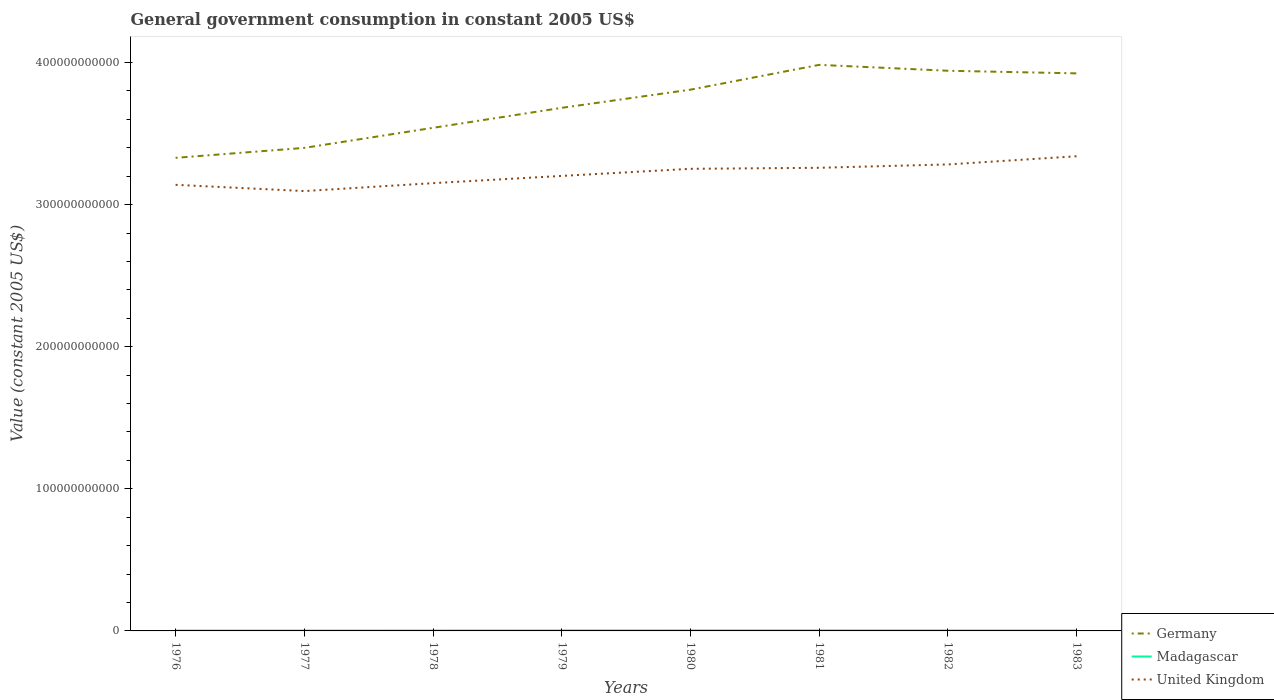How many different coloured lines are there?
Make the answer very short. 3. Does the line corresponding to Germany intersect with the line corresponding to Madagascar?
Keep it short and to the point. No. Across all years, what is the maximum government conusmption in Germany?
Your answer should be very brief. 3.33e+11. In which year was the government conusmption in United Kingdom maximum?
Provide a succinct answer. 1977. What is the total government conusmption in Germany in the graph?
Give a very brief answer. 4.15e+09. What is the difference between the highest and the second highest government conusmption in Madagascar?
Give a very brief answer. 7.58e+07. What is the difference between the highest and the lowest government conusmption in Madagascar?
Offer a terse response. 5. Is the government conusmption in United Kingdom strictly greater than the government conusmption in Madagascar over the years?
Your answer should be very brief. No. What is the difference between two consecutive major ticks on the Y-axis?
Provide a short and direct response. 1.00e+11. What is the title of the graph?
Provide a short and direct response. General government consumption in constant 2005 US$. Does "South Africa" appear as one of the legend labels in the graph?
Give a very brief answer. No. What is the label or title of the Y-axis?
Offer a very short reply. Value (constant 2005 US$). What is the Value (constant 2005 US$) of Germany in 1976?
Ensure brevity in your answer.  3.33e+11. What is the Value (constant 2005 US$) of Madagascar in 1976?
Keep it short and to the point. 2.77e+08. What is the Value (constant 2005 US$) in United Kingdom in 1976?
Ensure brevity in your answer.  3.14e+11. What is the Value (constant 2005 US$) of Germany in 1977?
Your answer should be compact. 3.40e+11. What is the Value (constant 2005 US$) in Madagascar in 1977?
Your answer should be compact. 2.79e+08. What is the Value (constant 2005 US$) of United Kingdom in 1977?
Your answer should be very brief. 3.10e+11. What is the Value (constant 2005 US$) of Germany in 1978?
Give a very brief answer. 3.54e+11. What is the Value (constant 2005 US$) in Madagascar in 1978?
Offer a terse response. 2.95e+08. What is the Value (constant 2005 US$) in United Kingdom in 1978?
Offer a very short reply. 3.15e+11. What is the Value (constant 2005 US$) in Germany in 1979?
Your answer should be compact. 3.68e+11. What is the Value (constant 2005 US$) in Madagascar in 1979?
Offer a terse response. 3.37e+08. What is the Value (constant 2005 US$) of United Kingdom in 1979?
Offer a terse response. 3.20e+11. What is the Value (constant 2005 US$) of Germany in 1980?
Offer a terse response. 3.81e+11. What is the Value (constant 2005 US$) in Madagascar in 1980?
Ensure brevity in your answer.  3.53e+08. What is the Value (constant 2005 US$) in United Kingdom in 1980?
Your answer should be compact. 3.25e+11. What is the Value (constant 2005 US$) in Germany in 1981?
Make the answer very short. 3.98e+11. What is the Value (constant 2005 US$) of Madagascar in 1981?
Your answer should be compact. 3.52e+08. What is the Value (constant 2005 US$) of United Kingdom in 1981?
Your answer should be very brief. 3.26e+11. What is the Value (constant 2005 US$) of Germany in 1982?
Your response must be concise. 3.94e+11. What is the Value (constant 2005 US$) in Madagascar in 1982?
Ensure brevity in your answer.  3.42e+08. What is the Value (constant 2005 US$) in United Kingdom in 1982?
Offer a very short reply. 3.28e+11. What is the Value (constant 2005 US$) in Germany in 1983?
Provide a succinct answer. 3.92e+11. What is the Value (constant 2005 US$) of Madagascar in 1983?
Make the answer very short. 3.43e+08. What is the Value (constant 2005 US$) in United Kingdom in 1983?
Keep it short and to the point. 3.34e+11. Across all years, what is the maximum Value (constant 2005 US$) in Germany?
Keep it short and to the point. 3.98e+11. Across all years, what is the maximum Value (constant 2005 US$) of Madagascar?
Ensure brevity in your answer.  3.53e+08. Across all years, what is the maximum Value (constant 2005 US$) of United Kingdom?
Offer a very short reply. 3.34e+11. Across all years, what is the minimum Value (constant 2005 US$) of Germany?
Give a very brief answer. 3.33e+11. Across all years, what is the minimum Value (constant 2005 US$) in Madagascar?
Your answer should be very brief. 2.77e+08. Across all years, what is the minimum Value (constant 2005 US$) of United Kingdom?
Offer a terse response. 3.10e+11. What is the total Value (constant 2005 US$) in Germany in the graph?
Ensure brevity in your answer.  2.96e+12. What is the total Value (constant 2005 US$) in Madagascar in the graph?
Keep it short and to the point. 2.58e+09. What is the total Value (constant 2005 US$) in United Kingdom in the graph?
Make the answer very short. 2.57e+12. What is the difference between the Value (constant 2005 US$) of Germany in 1976 and that in 1977?
Keep it short and to the point. -7.01e+09. What is the difference between the Value (constant 2005 US$) in Madagascar in 1976 and that in 1977?
Provide a succinct answer. -1.78e+06. What is the difference between the Value (constant 2005 US$) of United Kingdom in 1976 and that in 1977?
Make the answer very short. 4.39e+09. What is the difference between the Value (constant 2005 US$) in Germany in 1976 and that in 1978?
Your answer should be very brief. -2.11e+1. What is the difference between the Value (constant 2005 US$) of Madagascar in 1976 and that in 1978?
Keep it short and to the point. -1.78e+07. What is the difference between the Value (constant 2005 US$) of United Kingdom in 1976 and that in 1978?
Give a very brief answer. -1.18e+09. What is the difference between the Value (constant 2005 US$) of Germany in 1976 and that in 1979?
Your answer should be compact. -3.52e+1. What is the difference between the Value (constant 2005 US$) of Madagascar in 1976 and that in 1979?
Keep it short and to the point. -5.98e+07. What is the difference between the Value (constant 2005 US$) in United Kingdom in 1976 and that in 1979?
Offer a terse response. -6.27e+09. What is the difference between the Value (constant 2005 US$) in Germany in 1976 and that in 1980?
Give a very brief answer. -4.80e+1. What is the difference between the Value (constant 2005 US$) in Madagascar in 1976 and that in 1980?
Your response must be concise. -7.58e+07. What is the difference between the Value (constant 2005 US$) of United Kingdom in 1976 and that in 1980?
Provide a short and direct response. -1.13e+1. What is the difference between the Value (constant 2005 US$) of Germany in 1976 and that in 1981?
Offer a very short reply. -6.54e+1. What is the difference between the Value (constant 2005 US$) of Madagascar in 1976 and that in 1981?
Your answer should be compact. -7.52e+07. What is the difference between the Value (constant 2005 US$) in United Kingdom in 1976 and that in 1981?
Your answer should be very brief. -1.20e+1. What is the difference between the Value (constant 2005 US$) of Germany in 1976 and that in 1982?
Your answer should be very brief. -6.13e+1. What is the difference between the Value (constant 2005 US$) in Madagascar in 1976 and that in 1982?
Offer a terse response. -6.45e+07. What is the difference between the Value (constant 2005 US$) of United Kingdom in 1976 and that in 1982?
Keep it short and to the point. -1.43e+1. What is the difference between the Value (constant 2005 US$) in Germany in 1976 and that in 1983?
Keep it short and to the point. -5.94e+1. What is the difference between the Value (constant 2005 US$) of Madagascar in 1976 and that in 1983?
Keep it short and to the point. -6.57e+07. What is the difference between the Value (constant 2005 US$) of United Kingdom in 1976 and that in 1983?
Give a very brief answer. -2.01e+1. What is the difference between the Value (constant 2005 US$) of Germany in 1977 and that in 1978?
Ensure brevity in your answer.  -1.41e+1. What is the difference between the Value (constant 2005 US$) of Madagascar in 1977 and that in 1978?
Offer a very short reply. -1.60e+07. What is the difference between the Value (constant 2005 US$) of United Kingdom in 1977 and that in 1978?
Keep it short and to the point. -5.57e+09. What is the difference between the Value (constant 2005 US$) of Germany in 1977 and that in 1979?
Your answer should be compact. -2.82e+1. What is the difference between the Value (constant 2005 US$) in Madagascar in 1977 and that in 1979?
Provide a short and direct response. -5.80e+07. What is the difference between the Value (constant 2005 US$) of United Kingdom in 1977 and that in 1979?
Your answer should be very brief. -1.07e+1. What is the difference between the Value (constant 2005 US$) of Germany in 1977 and that in 1980?
Keep it short and to the point. -4.10e+1. What is the difference between the Value (constant 2005 US$) in Madagascar in 1977 and that in 1980?
Your response must be concise. -7.40e+07. What is the difference between the Value (constant 2005 US$) of United Kingdom in 1977 and that in 1980?
Ensure brevity in your answer.  -1.57e+1. What is the difference between the Value (constant 2005 US$) of Germany in 1977 and that in 1981?
Provide a succinct answer. -5.84e+1. What is the difference between the Value (constant 2005 US$) of Madagascar in 1977 and that in 1981?
Provide a short and direct response. -7.34e+07. What is the difference between the Value (constant 2005 US$) of United Kingdom in 1977 and that in 1981?
Provide a succinct answer. -1.64e+1. What is the difference between the Value (constant 2005 US$) in Germany in 1977 and that in 1982?
Your response must be concise. -5.43e+1. What is the difference between the Value (constant 2005 US$) of Madagascar in 1977 and that in 1982?
Ensure brevity in your answer.  -6.28e+07. What is the difference between the Value (constant 2005 US$) in United Kingdom in 1977 and that in 1982?
Keep it short and to the point. -1.87e+1. What is the difference between the Value (constant 2005 US$) of Germany in 1977 and that in 1983?
Give a very brief answer. -5.24e+1. What is the difference between the Value (constant 2005 US$) in Madagascar in 1977 and that in 1983?
Keep it short and to the point. -6.39e+07. What is the difference between the Value (constant 2005 US$) of United Kingdom in 1977 and that in 1983?
Make the answer very short. -2.45e+1. What is the difference between the Value (constant 2005 US$) in Germany in 1978 and that in 1979?
Offer a very short reply. -1.41e+1. What is the difference between the Value (constant 2005 US$) in Madagascar in 1978 and that in 1979?
Ensure brevity in your answer.  -4.20e+07. What is the difference between the Value (constant 2005 US$) in United Kingdom in 1978 and that in 1979?
Ensure brevity in your answer.  -5.10e+09. What is the difference between the Value (constant 2005 US$) of Germany in 1978 and that in 1980?
Give a very brief answer. -2.69e+1. What is the difference between the Value (constant 2005 US$) in Madagascar in 1978 and that in 1980?
Your answer should be very brief. -5.80e+07. What is the difference between the Value (constant 2005 US$) in United Kingdom in 1978 and that in 1980?
Give a very brief answer. -1.01e+1. What is the difference between the Value (constant 2005 US$) in Germany in 1978 and that in 1981?
Your response must be concise. -4.43e+1. What is the difference between the Value (constant 2005 US$) in Madagascar in 1978 and that in 1981?
Offer a terse response. -5.74e+07. What is the difference between the Value (constant 2005 US$) in United Kingdom in 1978 and that in 1981?
Make the answer very short. -1.08e+1. What is the difference between the Value (constant 2005 US$) of Germany in 1978 and that in 1982?
Offer a terse response. -4.02e+1. What is the difference between the Value (constant 2005 US$) of Madagascar in 1978 and that in 1982?
Offer a very short reply. -4.68e+07. What is the difference between the Value (constant 2005 US$) in United Kingdom in 1978 and that in 1982?
Provide a short and direct response. -1.32e+1. What is the difference between the Value (constant 2005 US$) in Germany in 1978 and that in 1983?
Make the answer very short. -3.83e+1. What is the difference between the Value (constant 2005 US$) of Madagascar in 1978 and that in 1983?
Your response must be concise. -4.80e+07. What is the difference between the Value (constant 2005 US$) of United Kingdom in 1978 and that in 1983?
Your answer should be compact. -1.89e+1. What is the difference between the Value (constant 2005 US$) of Germany in 1979 and that in 1980?
Offer a terse response. -1.28e+1. What is the difference between the Value (constant 2005 US$) in Madagascar in 1979 and that in 1980?
Make the answer very short. -1.60e+07. What is the difference between the Value (constant 2005 US$) of United Kingdom in 1979 and that in 1980?
Your response must be concise. -4.99e+09. What is the difference between the Value (constant 2005 US$) of Germany in 1979 and that in 1981?
Your answer should be very brief. -3.02e+1. What is the difference between the Value (constant 2005 US$) of Madagascar in 1979 and that in 1981?
Make the answer very short. -1.54e+07. What is the difference between the Value (constant 2005 US$) of United Kingdom in 1979 and that in 1981?
Offer a terse response. -5.72e+09. What is the difference between the Value (constant 2005 US$) in Germany in 1979 and that in 1982?
Give a very brief answer. -2.61e+1. What is the difference between the Value (constant 2005 US$) of Madagascar in 1979 and that in 1982?
Your response must be concise. -4.74e+06. What is the difference between the Value (constant 2005 US$) of United Kingdom in 1979 and that in 1982?
Offer a terse response. -8.08e+09. What is the difference between the Value (constant 2005 US$) in Germany in 1979 and that in 1983?
Provide a succinct answer. -2.42e+1. What is the difference between the Value (constant 2005 US$) of Madagascar in 1979 and that in 1983?
Your answer should be compact. -5.92e+06. What is the difference between the Value (constant 2005 US$) in United Kingdom in 1979 and that in 1983?
Offer a very short reply. -1.38e+1. What is the difference between the Value (constant 2005 US$) of Germany in 1980 and that in 1981?
Keep it short and to the point. -1.74e+1. What is the difference between the Value (constant 2005 US$) of Madagascar in 1980 and that in 1981?
Give a very brief answer. 5.92e+05. What is the difference between the Value (constant 2005 US$) of United Kingdom in 1980 and that in 1981?
Provide a succinct answer. -7.25e+08. What is the difference between the Value (constant 2005 US$) in Germany in 1980 and that in 1982?
Give a very brief answer. -1.33e+1. What is the difference between the Value (constant 2005 US$) of Madagascar in 1980 and that in 1982?
Make the answer very short. 1.13e+07. What is the difference between the Value (constant 2005 US$) in United Kingdom in 1980 and that in 1982?
Your answer should be very brief. -3.09e+09. What is the difference between the Value (constant 2005 US$) of Germany in 1980 and that in 1983?
Ensure brevity in your answer.  -1.15e+1. What is the difference between the Value (constant 2005 US$) in Madagascar in 1980 and that in 1983?
Keep it short and to the point. 1.01e+07. What is the difference between the Value (constant 2005 US$) in United Kingdom in 1980 and that in 1983?
Ensure brevity in your answer.  -8.85e+09. What is the difference between the Value (constant 2005 US$) in Germany in 1981 and that in 1982?
Provide a short and direct response. 4.15e+09. What is the difference between the Value (constant 2005 US$) of Madagascar in 1981 and that in 1982?
Make the answer very short. 1.07e+07. What is the difference between the Value (constant 2005 US$) in United Kingdom in 1981 and that in 1982?
Your answer should be very brief. -2.36e+09. What is the difference between the Value (constant 2005 US$) of Germany in 1981 and that in 1983?
Offer a very short reply. 5.99e+09. What is the difference between the Value (constant 2005 US$) in Madagascar in 1981 and that in 1983?
Keep it short and to the point. 9.47e+06. What is the difference between the Value (constant 2005 US$) of United Kingdom in 1981 and that in 1983?
Your response must be concise. -8.13e+09. What is the difference between the Value (constant 2005 US$) in Germany in 1982 and that in 1983?
Keep it short and to the point. 1.84e+09. What is the difference between the Value (constant 2005 US$) of Madagascar in 1982 and that in 1983?
Make the answer very short. -1.18e+06. What is the difference between the Value (constant 2005 US$) of United Kingdom in 1982 and that in 1983?
Provide a succinct answer. -5.77e+09. What is the difference between the Value (constant 2005 US$) in Germany in 1976 and the Value (constant 2005 US$) in Madagascar in 1977?
Make the answer very short. 3.33e+11. What is the difference between the Value (constant 2005 US$) in Germany in 1976 and the Value (constant 2005 US$) in United Kingdom in 1977?
Offer a very short reply. 2.34e+1. What is the difference between the Value (constant 2005 US$) in Madagascar in 1976 and the Value (constant 2005 US$) in United Kingdom in 1977?
Give a very brief answer. -3.09e+11. What is the difference between the Value (constant 2005 US$) of Germany in 1976 and the Value (constant 2005 US$) of Madagascar in 1978?
Keep it short and to the point. 3.33e+11. What is the difference between the Value (constant 2005 US$) of Germany in 1976 and the Value (constant 2005 US$) of United Kingdom in 1978?
Your answer should be very brief. 1.78e+1. What is the difference between the Value (constant 2005 US$) in Madagascar in 1976 and the Value (constant 2005 US$) in United Kingdom in 1978?
Make the answer very short. -3.15e+11. What is the difference between the Value (constant 2005 US$) in Germany in 1976 and the Value (constant 2005 US$) in Madagascar in 1979?
Give a very brief answer. 3.33e+11. What is the difference between the Value (constant 2005 US$) in Germany in 1976 and the Value (constant 2005 US$) in United Kingdom in 1979?
Offer a terse response. 1.27e+1. What is the difference between the Value (constant 2005 US$) of Madagascar in 1976 and the Value (constant 2005 US$) of United Kingdom in 1979?
Your response must be concise. -3.20e+11. What is the difference between the Value (constant 2005 US$) of Germany in 1976 and the Value (constant 2005 US$) of Madagascar in 1980?
Offer a very short reply. 3.33e+11. What is the difference between the Value (constant 2005 US$) of Germany in 1976 and the Value (constant 2005 US$) of United Kingdom in 1980?
Provide a succinct answer. 7.72e+09. What is the difference between the Value (constant 2005 US$) of Madagascar in 1976 and the Value (constant 2005 US$) of United Kingdom in 1980?
Provide a succinct answer. -3.25e+11. What is the difference between the Value (constant 2005 US$) of Germany in 1976 and the Value (constant 2005 US$) of Madagascar in 1981?
Offer a very short reply. 3.33e+11. What is the difference between the Value (constant 2005 US$) in Germany in 1976 and the Value (constant 2005 US$) in United Kingdom in 1981?
Offer a very short reply. 7.00e+09. What is the difference between the Value (constant 2005 US$) in Madagascar in 1976 and the Value (constant 2005 US$) in United Kingdom in 1981?
Provide a short and direct response. -3.26e+11. What is the difference between the Value (constant 2005 US$) in Germany in 1976 and the Value (constant 2005 US$) in Madagascar in 1982?
Offer a terse response. 3.33e+11. What is the difference between the Value (constant 2005 US$) of Germany in 1976 and the Value (constant 2005 US$) of United Kingdom in 1982?
Offer a terse response. 4.64e+09. What is the difference between the Value (constant 2005 US$) in Madagascar in 1976 and the Value (constant 2005 US$) in United Kingdom in 1982?
Your answer should be very brief. -3.28e+11. What is the difference between the Value (constant 2005 US$) in Germany in 1976 and the Value (constant 2005 US$) in Madagascar in 1983?
Give a very brief answer. 3.33e+11. What is the difference between the Value (constant 2005 US$) in Germany in 1976 and the Value (constant 2005 US$) in United Kingdom in 1983?
Offer a very short reply. -1.13e+09. What is the difference between the Value (constant 2005 US$) in Madagascar in 1976 and the Value (constant 2005 US$) in United Kingdom in 1983?
Offer a terse response. -3.34e+11. What is the difference between the Value (constant 2005 US$) of Germany in 1977 and the Value (constant 2005 US$) of Madagascar in 1978?
Offer a terse response. 3.40e+11. What is the difference between the Value (constant 2005 US$) of Germany in 1977 and the Value (constant 2005 US$) of United Kingdom in 1978?
Make the answer very short. 2.48e+1. What is the difference between the Value (constant 2005 US$) in Madagascar in 1977 and the Value (constant 2005 US$) in United Kingdom in 1978?
Keep it short and to the point. -3.15e+11. What is the difference between the Value (constant 2005 US$) of Germany in 1977 and the Value (constant 2005 US$) of Madagascar in 1979?
Your answer should be very brief. 3.40e+11. What is the difference between the Value (constant 2005 US$) of Germany in 1977 and the Value (constant 2005 US$) of United Kingdom in 1979?
Provide a short and direct response. 1.97e+1. What is the difference between the Value (constant 2005 US$) in Madagascar in 1977 and the Value (constant 2005 US$) in United Kingdom in 1979?
Your answer should be compact. -3.20e+11. What is the difference between the Value (constant 2005 US$) of Germany in 1977 and the Value (constant 2005 US$) of Madagascar in 1980?
Provide a short and direct response. 3.40e+11. What is the difference between the Value (constant 2005 US$) of Germany in 1977 and the Value (constant 2005 US$) of United Kingdom in 1980?
Keep it short and to the point. 1.47e+1. What is the difference between the Value (constant 2005 US$) in Madagascar in 1977 and the Value (constant 2005 US$) in United Kingdom in 1980?
Offer a terse response. -3.25e+11. What is the difference between the Value (constant 2005 US$) in Germany in 1977 and the Value (constant 2005 US$) in Madagascar in 1981?
Your answer should be very brief. 3.40e+11. What is the difference between the Value (constant 2005 US$) in Germany in 1977 and the Value (constant 2005 US$) in United Kingdom in 1981?
Give a very brief answer. 1.40e+1. What is the difference between the Value (constant 2005 US$) of Madagascar in 1977 and the Value (constant 2005 US$) of United Kingdom in 1981?
Your response must be concise. -3.26e+11. What is the difference between the Value (constant 2005 US$) in Germany in 1977 and the Value (constant 2005 US$) in Madagascar in 1982?
Provide a short and direct response. 3.40e+11. What is the difference between the Value (constant 2005 US$) of Germany in 1977 and the Value (constant 2005 US$) of United Kingdom in 1982?
Provide a succinct answer. 1.16e+1. What is the difference between the Value (constant 2005 US$) of Madagascar in 1977 and the Value (constant 2005 US$) of United Kingdom in 1982?
Your answer should be compact. -3.28e+11. What is the difference between the Value (constant 2005 US$) in Germany in 1977 and the Value (constant 2005 US$) in Madagascar in 1983?
Provide a succinct answer. 3.40e+11. What is the difference between the Value (constant 2005 US$) of Germany in 1977 and the Value (constant 2005 US$) of United Kingdom in 1983?
Offer a terse response. 5.88e+09. What is the difference between the Value (constant 2005 US$) of Madagascar in 1977 and the Value (constant 2005 US$) of United Kingdom in 1983?
Ensure brevity in your answer.  -3.34e+11. What is the difference between the Value (constant 2005 US$) of Germany in 1978 and the Value (constant 2005 US$) of Madagascar in 1979?
Make the answer very short. 3.54e+11. What is the difference between the Value (constant 2005 US$) in Germany in 1978 and the Value (constant 2005 US$) in United Kingdom in 1979?
Ensure brevity in your answer.  3.38e+1. What is the difference between the Value (constant 2005 US$) of Madagascar in 1978 and the Value (constant 2005 US$) of United Kingdom in 1979?
Offer a terse response. -3.20e+11. What is the difference between the Value (constant 2005 US$) of Germany in 1978 and the Value (constant 2005 US$) of Madagascar in 1980?
Your answer should be compact. 3.54e+11. What is the difference between the Value (constant 2005 US$) in Germany in 1978 and the Value (constant 2005 US$) in United Kingdom in 1980?
Give a very brief answer. 2.88e+1. What is the difference between the Value (constant 2005 US$) of Madagascar in 1978 and the Value (constant 2005 US$) of United Kingdom in 1980?
Provide a short and direct response. -3.25e+11. What is the difference between the Value (constant 2005 US$) of Germany in 1978 and the Value (constant 2005 US$) of Madagascar in 1981?
Offer a very short reply. 3.54e+11. What is the difference between the Value (constant 2005 US$) of Germany in 1978 and the Value (constant 2005 US$) of United Kingdom in 1981?
Give a very brief answer. 2.81e+1. What is the difference between the Value (constant 2005 US$) of Madagascar in 1978 and the Value (constant 2005 US$) of United Kingdom in 1981?
Your answer should be compact. -3.26e+11. What is the difference between the Value (constant 2005 US$) of Germany in 1978 and the Value (constant 2005 US$) of Madagascar in 1982?
Offer a very short reply. 3.54e+11. What is the difference between the Value (constant 2005 US$) in Germany in 1978 and the Value (constant 2005 US$) in United Kingdom in 1982?
Your answer should be very brief. 2.58e+1. What is the difference between the Value (constant 2005 US$) of Madagascar in 1978 and the Value (constant 2005 US$) of United Kingdom in 1982?
Keep it short and to the point. -3.28e+11. What is the difference between the Value (constant 2005 US$) of Germany in 1978 and the Value (constant 2005 US$) of Madagascar in 1983?
Your answer should be very brief. 3.54e+11. What is the difference between the Value (constant 2005 US$) of Germany in 1978 and the Value (constant 2005 US$) of United Kingdom in 1983?
Give a very brief answer. 2.00e+1. What is the difference between the Value (constant 2005 US$) of Madagascar in 1978 and the Value (constant 2005 US$) of United Kingdom in 1983?
Ensure brevity in your answer.  -3.34e+11. What is the difference between the Value (constant 2005 US$) of Germany in 1979 and the Value (constant 2005 US$) of Madagascar in 1980?
Provide a short and direct response. 3.68e+11. What is the difference between the Value (constant 2005 US$) of Germany in 1979 and the Value (constant 2005 US$) of United Kingdom in 1980?
Ensure brevity in your answer.  4.29e+1. What is the difference between the Value (constant 2005 US$) of Madagascar in 1979 and the Value (constant 2005 US$) of United Kingdom in 1980?
Keep it short and to the point. -3.25e+11. What is the difference between the Value (constant 2005 US$) in Germany in 1979 and the Value (constant 2005 US$) in Madagascar in 1981?
Your answer should be compact. 3.68e+11. What is the difference between the Value (constant 2005 US$) of Germany in 1979 and the Value (constant 2005 US$) of United Kingdom in 1981?
Provide a succinct answer. 4.22e+1. What is the difference between the Value (constant 2005 US$) in Madagascar in 1979 and the Value (constant 2005 US$) in United Kingdom in 1981?
Provide a short and direct response. -3.26e+11. What is the difference between the Value (constant 2005 US$) in Germany in 1979 and the Value (constant 2005 US$) in Madagascar in 1982?
Give a very brief answer. 3.68e+11. What is the difference between the Value (constant 2005 US$) of Germany in 1979 and the Value (constant 2005 US$) of United Kingdom in 1982?
Your answer should be compact. 3.98e+1. What is the difference between the Value (constant 2005 US$) of Madagascar in 1979 and the Value (constant 2005 US$) of United Kingdom in 1982?
Offer a terse response. -3.28e+11. What is the difference between the Value (constant 2005 US$) in Germany in 1979 and the Value (constant 2005 US$) in Madagascar in 1983?
Your response must be concise. 3.68e+11. What is the difference between the Value (constant 2005 US$) in Germany in 1979 and the Value (constant 2005 US$) in United Kingdom in 1983?
Keep it short and to the point. 3.41e+1. What is the difference between the Value (constant 2005 US$) in Madagascar in 1979 and the Value (constant 2005 US$) in United Kingdom in 1983?
Your response must be concise. -3.34e+11. What is the difference between the Value (constant 2005 US$) in Germany in 1980 and the Value (constant 2005 US$) in Madagascar in 1981?
Keep it short and to the point. 3.81e+11. What is the difference between the Value (constant 2005 US$) in Germany in 1980 and the Value (constant 2005 US$) in United Kingdom in 1981?
Provide a short and direct response. 5.50e+1. What is the difference between the Value (constant 2005 US$) of Madagascar in 1980 and the Value (constant 2005 US$) of United Kingdom in 1981?
Give a very brief answer. -3.26e+11. What is the difference between the Value (constant 2005 US$) in Germany in 1980 and the Value (constant 2005 US$) in Madagascar in 1982?
Provide a succinct answer. 3.81e+11. What is the difference between the Value (constant 2005 US$) of Germany in 1980 and the Value (constant 2005 US$) of United Kingdom in 1982?
Provide a short and direct response. 5.26e+1. What is the difference between the Value (constant 2005 US$) of Madagascar in 1980 and the Value (constant 2005 US$) of United Kingdom in 1982?
Offer a terse response. -3.28e+11. What is the difference between the Value (constant 2005 US$) of Germany in 1980 and the Value (constant 2005 US$) of Madagascar in 1983?
Offer a very short reply. 3.81e+11. What is the difference between the Value (constant 2005 US$) of Germany in 1980 and the Value (constant 2005 US$) of United Kingdom in 1983?
Your answer should be very brief. 4.69e+1. What is the difference between the Value (constant 2005 US$) in Madagascar in 1980 and the Value (constant 2005 US$) in United Kingdom in 1983?
Offer a very short reply. -3.34e+11. What is the difference between the Value (constant 2005 US$) of Germany in 1981 and the Value (constant 2005 US$) of Madagascar in 1982?
Provide a succinct answer. 3.98e+11. What is the difference between the Value (constant 2005 US$) in Germany in 1981 and the Value (constant 2005 US$) in United Kingdom in 1982?
Keep it short and to the point. 7.01e+1. What is the difference between the Value (constant 2005 US$) of Madagascar in 1981 and the Value (constant 2005 US$) of United Kingdom in 1982?
Your response must be concise. -3.28e+11. What is the difference between the Value (constant 2005 US$) in Germany in 1981 and the Value (constant 2005 US$) in Madagascar in 1983?
Provide a succinct answer. 3.98e+11. What is the difference between the Value (constant 2005 US$) of Germany in 1981 and the Value (constant 2005 US$) of United Kingdom in 1983?
Make the answer very short. 6.43e+1. What is the difference between the Value (constant 2005 US$) of Madagascar in 1981 and the Value (constant 2005 US$) of United Kingdom in 1983?
Provide a short and direct response. -3.34e+11. What is the difference between the Value (constant 2005 US$) of Germany in 1982 and the Value (constant 2005 US$) of Madagascar in 1983?
Provide a succinct answer. 3.94e+11. What is the difference between the Value (constant 2005 US$) of Germany in 1982 and the Value (constant 2005 US$) of United Kingdom in 1983?
Give a very brief answer. 6.02e+1. What is the difference between the Value (constant 2005 US$) in Madagascar in 1982 and the Value (constant 2005 US$) in United Kingdom in 1983?
Offer a very short reply. -3.34e+11. What is the average Value (constant 2005 US$) in Germany per year?
Offer a very short reply. 3.70e+11. What is the average Value (constant 2005 US$) of Madagascar per year?
Provide a short and direct response. 3.22e+08. What is the average Value (constant 2005 US$) of United Kingdom per year?
Provide a succinct answer. 3.22e+11. In the year 1976, what is the difference between the Value (constant 2005 US$) in Germany and Value (constant 2005 US$) in Madagascar?
Keep it short and to the point. 3.33e+11. In the year 1976, what is the difference between the Value (constant 2005 US$) of Germany and Value (constant 2005 US$) of United Kingdom?
Your response must be concise. 1.90e+1. In the year 1976, what is the difference between the Value (constant 2005 US$) of Madagascar and Value (constant 2005 US$) of United Kingdom?
Give a very brief answer. -3.14e+11. In the year 1977, what is the difference between the Value (constant 2005 US$) in Germany and Value (constant 2005 US$) in Madagascar?
Your answer should be compact. 3.40e+11. In the year 1977, what is the difference between the Value (constant 2005 US$) in Germany and Value (constant 2005 US$) in United Kingdom?
Ensure brevity in your answer.  3.04e+1. In the year 1977, what is the difference between the Value (constant 2005 US$) in Madagascar and Value (constant 2005 US$) in United Kingdom?
Give a very brief answer. -3.09e+11. In the year 1978, what is the difference between the Value (constant 2005 US$) in Germany and Value (constant 2005 US$) in Madagascar?
Keep it short and to the point. 3.54e+11. In the year 1978, what is the difference between the Value (constant 2005 US$) in Germany and Value (constant 2005 US$) in United Kingdom?
Ensure brevity in your answer.  3.89e+1. In the year 1978, what is the difference between the Value (constant 2005 US$) in Madagascar and Value (constant 2005 US$) in United Kingdom?
Offer a very short reply. -3.15e+11. In the year 1979, what is the difference between the Value (constant 2005 US$) of Germany and Value (constant 2005 US$) of Madagascar?
Give a very brief answer. 3.68e+11. In the year 1979, what is the difference between the Value (constant 2005 US$) in Germany and Value (constant 2005 US$) in United Kingdom?
Offer a terse response. 4.79e+1. In the year 1979, what is the difference between the Value (constant 2005 US$) of Madagascar and Value (constant 2005 US$) of United Kingdom?
Your response must be concise. -3.20e+11. In the year 1980, what is the difference between the Value (constant 2005 US$) of Germany and Value (constant 2005 US$) of Madagascar?
Keep it short and to the point. 3.81e+11. In the year 1980, what is the difference between the Value (constant 2005 US$) in Germany and Value (constant 2005 US$) in United Kingdom?
Your answer should be compact. 5.57e+1. In the year 1980, what is the difference between the Value (constant 2005 US$) in Madagascar and Value (constant 2005 US$) in United Kingdom?
Your response must be concise. -3.25e+11. In the year 1981, what is the difference between the Value (constant 2005 US$) of Germany and Value (constant 2005 US$) of Madagascar?
Keep it short and to the point. 3.98e+11. In the year 1981, what is the difference between the Value (constant 2005 US$) in Germany and Value (constant 2005 US$) in United Kingdom?
Your answer should be compact. 7.24e+1. In the year 1981, what is the difference between the Value (constant 2005 US$) in Madagascar and Value (constant 2005 US$) in United Kingdom?
Keep it short and to the point. -3.26e+11. In the year 1982, what is the difference between the Value (constant 2005 US$) of Germany and Value (constant 2005 US$) of Madagascar?
Provide a short and direct response. 3.94e+11. In the year 1982, what is the difference between the Value (constant 2005 US$) of Germany and Value (constant 2005 US$) of United Kingdom?
Ensure brevity in your answer.  6.59e+1. In the year 1982, what is the difference between the Value (constant 2005 US$) in Madagascar and Value (constant 2005 US$) in United Kingdom?
Provide a succinct answer. -3.28e+11. In the year 1983, what is the difference between the Value (constant 2005 US$) of Germany and Value (constant 2005 US$) of Madagascar?
Ensure brevity in your answer.  3.92e+11. In the year 1983, what is the difference between the Value (constant 2005 US$) of Germany and Value (constant 2005 US$) of United Kingdom?
Your response must be concise. 5.83e+1. In the year 1983, what is the difference between the Value (constant 2005 US$) of Madagascar and Value (constant 2005 US$) of United Kingdom?
Your answer should be very brief. -3.34e+11. What is the ratio of the Value (constant 2005 US$) in Germany in 1976 to that in 1977?
Keep it short and to the point. 0.98. What is the ratio of the Value (constant 2005 US$) in Madagascar in 1976 to that in 1977?
Make the answer very short. 0.99. What is the ratio of the Value (constant 2005 US$) of United Kingdom in 1976 to that in 1977?
Ensure brevity in your answer.  1.01. What is the ratio of the Value (constant 2005 US$) of Germany in 1976 to that in 1978?
Your response must be concise. 0.94. What is the ratio of the Value (constant 2005 US$) in Madagascar in 1976 to that in 1978?
Your answer should be very brief. 0.94. What is the ratio of the Value (constant 2005 US$) in Germany in 1976 to that in 1979?
Your answer should be very brief. 0.9. What is the ratio of the Value (constant 2005 US$) in Madagascar in 1976 to that in 1979?
Make the answer very short. 0.82. What is the ratio of the Value (constant 2005 US$) in United Kingdom in 1976 to that in 1979?
Provide a short and direct response. 0.98. What is the ratio of the Value (constant 2005 US$) in Germany in 1976 to that in 1980?
Offer a very short reply. 0.87. What is the ratio of the Value (constant 2005 US$) in Madagascar in 1976 to that in 1980?
Ensure brevity in your answer.  0.79. What is the ratio of the Value (constant 2005 US$) of United Kingdom in 1976 to that in 1980?
Make the answer very short. 0.97. What is the ratio of the Value (constant 2005 US$) in Germany in 1976 to that in 1981?
Offer a very short reply. 0.84. What is the ratio of the Value (constant 2005 US$) in Madagascar in 1976 to that in 1981?
Make the answer very short. 0.79. What is the ratio of the Value (constant 2005 US$) of United Kingdom in 1976 to that in 1981?
Your response must be concise. 0.96. What is the ratio of the Value (constant 2005 US$) in Germany in 1976 to that in 1982?
Offer a very short reply. 0.84. What is the ratio of the Value (constant 2005 US$) of Madagascar in 1976 to that in 1982?
Your answer should be compact. 0.81. What is the ratio of the Value (constant 2005 US$) in United Kingdom in 1976 to that in 1982?
Provide a succinct answer. 0.96. What is the ratio of the Value (constant 2005 US$) of Germany in 1976 to that in 1983?
Keep it short and to the point. 0.85. What is the ratio of the Value (constant 2005 US$) of Madagascar in 1976 to that in 1983?
Your answer should be very brief. 0.81. What is the ratio of the Value (constant 2005 US$) of United Kingdom in 1976 to that in 1983?
Your answer should be very brief. 0.94. What is the ratio of the Value (constant 2005 US$) in Germany in 1977 to that in 1978?
Give a very brief answer. 0.96. What is the ratio of the Value (constant 2005 US$) in Madagascar in 1977 to that in 1978?
Ensure brevity in your answer.  0.95. What is the ratio of the Value (constant 2005 US$) in United Kingdom in 1977 to that in 1978?
Offer a very short reply. 0.98. What is the ratio of the Value (constant 2005 US$) of Germany in 1977 to that in 1979?
Your response must be concise. 0.92. What is the ratio of the Value (constant 2005 US$) in Madagascar in 1977 to that in 1979?
Ensure brevity in your answer.  0.83. What is the ratio of the Value (constant 2005 US$) in United Kingdom in 1977 to that in 1979?
Provide a succinct answer. 0.97. What is the ratio of the Value (constant 2005 US$) in Germany in 1977 to that in 1980?
Provide a succinct answer. 0.89. What is the ratio of the Value (constant 2005 US$) in Madagascar in 1977 to that in 1980?
Provide a succinct answer. 0.79. What is the ratio of the Value (constant 2005 US$) of United Kingdom in 1977 to that in 1980?
Keep it short and to the point. 0.95. What is the ratio of the Value (constant 2005 US$) in Germany in 1977 to that in 1981?
Ensure brevity in your answer.  0.85. What is the ratio of the Value (constant 2005 US$) of Madagascar in 1977 to that in 1981?
Ensure brevity in your answer.  0.79. What is the ratio of the Value (constant 2005 US$) in United Kingdom in 1977 to that in 1981?
Offer a terse response. 0.95. What is the ratio of the Value (constant 2005 US$) of Germany in 1977 to that in 1982?
Ensure brevity in your answer.  0.86. What is the ratio of the Value (constant 2005 US$) in Madagascar in 1977 to that in 1982?
Your answer should be compact. 0.82. What is the ratio of the Value (constant 2005 US$) of United Kingdom in 1977 to that in 1982?
Your response must be concise. 0.94. What is the ratio of the Value (constant 2005 US$) of Germany in 1977 to that in 1983?
Provide a succinct answer. 0.87. What is the ratio of the Value (constant 2005 US$) of Madagascar in 1977 to that in 1983?
Your answer should be very brief. 0.81. What is the ratio of the Value (constant 2005 US$) of United Kingdom in 1977 to that in 1983?
Give a very brief answer. 0.93. What is the ratio of the Value (constant 2005 US$) in Germany in 1978 to that in 1979?
Keep it short and to the point. 0.96. What is the ratio of the Value (constant 2005 US$) in Madagascar in 1978 to that in 1979?
Offer a terse response. 0.88. What is the ratio of the Value (constant 2005 US$) of United Kingdom in 1978 to that in 1979?
Offer a very short reply. 0.98. What is the ratio of the Value (constant 2005 US$) of Germany in 1978 to that in 1980?
Give a very brief answer. 0.93. What is the ratio of the Value (constant 2005 US$) in Madagascar in 1978 to that in 1980?
Keep it short and to the point. 0.84. What is the ratio of the Value (constant 2005 US$) in United Kingdom in 1978 to that in 1980?
Offer a very short reply. 0.97. What is the ratio of the Value (constant 2005 US$) of Germany in 1978 to that in 1981?
Provide a succinct answer. 0.89. What is the ratio of the Value (constant 2005 US$) of Madagascar in 1978 to that in 1981?
Give a very brief answer. 0.84. What is the ratio of the Value (constant 2005 US$) of United Kingdom in 1978 to that in 1981?
Ensure brevity in your answer.  0.97. What is the ratio of the Value (constant 2005 US$) of Germany in 1978 to that in 1982?
Your answer should be compact. 0.9. What is the ratio of the Value (constant 2005 US$) of Madagascar in 1978 to that in 1982?
Ensure brevity in your answer.  0.86. What is the ratio of the Value (constant 2005 US$) in United Kingdom in 1978 to that in 1982?
Offer a very short reply. 0.96. What is the ratio of the Value (constant 2005 US$) of Germany in 1978 to that in 1983?
Offer a very short reply. 0.9. What is the ratio of the Value (constant 2005 US$) in Madagascar in 1978 to that in 1983?
Provide a short and direct response. 0.86. What is the ratio of the Value (constant 2005 US$) of United Kingdom in 1978 to that in 1983?
Your answer should be very brief. 0.94. What is the ratio of the Value (constant 2005 US$) in Germany in 1979 to that in 1980?
Make the answer very short. 0.97. What is the ratio of the Value (constant 2005 US$) in Madagascar in 1979 to that in 1980?
Provide a short and direct response. 0.95. What is the ratio of the Value (constant 2005 US$) of United Kingdom in 1979 to that in 1980?
Make the answer very short. 0.98. What is the ratio of the Value (constant 2005 US$) of Germany in 1979 to that in 1981?
Offer a terse response. 0.92. What is the ratio of the Value (constant 2005 US$) of Madagascar in 1979 to that in 1981?
Provide a succinct answer. 0.96. What is the ratio of the Value (constant 2005 US$) of United Kingdom in 1979 to that in 1981?
Make the answer very short. 0.98. What is the ratio of the Value (constant 2005 US$) in Germany in 1979 to that in 1982?
Your answer should be compact. 0.93. What is the ratio of the Value (constant 2005 US$) in Madagascar in 1979 to that in 1982?
Your answer should be compact. 0.99. What is the ratio of the Value (constant 2005 US$) of United Kingdom in 1979 to that in 1982?
Provide a short and direct response. 0.98. What is the ratio of the Value (constant 2005 US$) in Germany in 1979 to that in 1983?
Make the answer very short. 0.94. What is the ratio of the Value (constant 2005 US$) of Madagascar in 1979 to that in 1983?
Give a very brief answer. 0.98. What is the ratio of the Value (constant 2005 US$) in United Kingdom in 1979 to that in 1983?
Keep it short and to the point. 0.96. What is the ratio of the Value (constant 2005 US$) in Germany in 1980 to that in 1981?
Keep it short and to the point. 0.96. What is the ratio of the Value (constant 2005 US$) in Germany in 1980 to that in 1982?
Offer a very short reply. 0.97. What is the ratio of the Value (constant 2005 US$) in Madagascar in 1980 to that in 1982?
Make the answer very short. 1.03. What is the ratio of the Value (constant 2005 US$) in United Kingdom in 1980 to that in 1982?
Provide a short and direct response. 0.99. What is the ratio of the Value (constant 2005 US$) in Germany in 1980 to that in 1983?
Make the answer very short. 0.97. What is the ratio of the Value (constant 2005 US$) in Madagascar in 1980 to that in 1983?
Your answer should be very brief. 1.03. What is the ratio of the Value (constant 2005 US$) of United Kingdom in 1980 to that in 1983?
Provide a short and direct response. 0.97. What is the ratio of the Value (constant 2005 US$) of Germany in 1981 to that in 1982?
Keep it short and to the point. 1.01. What is the ratio of the Value (constant 2005 US$) of Madagascar in 1981 to that in 1982?
Your response must be concise. 1.03. What is the ratio of the Value (constant 2005 US$) of Germany in 1981 to that in 1983?
Your answer should be very brief. 1.02. What is the ratio of the Value (constant 2005 US$) in Madagascar in 1981 to that in 1983?
Provide a succinct answer. 1.03. What is the ratio of the Value (constant 2005 US$) of United Kingdom in 1981 to that in 1983?
Ensure brevity in your answer.  0.98. What is the ratio of the Value (constant 2005 US$) in Germany in 1982 to that in 1983?
Provide a short and direct response. 1. What is the ratio of the Value (constant 2005 US$) of United Kingdom in 1982 to that in 1983?
Provide a succinct answer. 0.98. What is the difference between the highest and the second highest Value (constant 2005 US$) of Germany?
Keep it short and to the point. 4.15e+09. What is the difference between the highest and the second highest Value (constant 2005 US$) in Madagascar?
Provide a succinct answer. 5.92e+05. What is the difference between the highest and the second highest Value (constant 2005 US$) of United Kingdom?
Offer a terse response. 5.77e+09. What is the difference between the highest and the lowest Value (constant 2005 US$) in Germany?
Provide a succinct answer. 6.54e+1. What is the difference between the highest and the lowest Value (constant 2005 US$) in Madagascar?
Offer a very short reply. 7.58e+07. What is the difference between the highest and the lowest Value (constant 2005 US$) of United Kingdom?
Provide a short and direct response. 2.45e+1. 